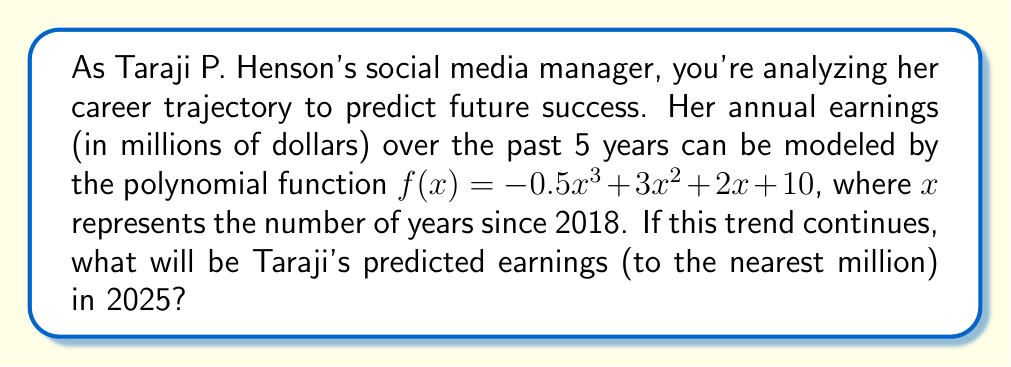Solve this math problem. To solve this problem, we need to follow these steps:

1. Identify the year we're predicting for: 2025
2. Calculate how many years this is from our starting point (2018)
3. Plug this value into our polynomial function
4. Round the result to the nearest million

Step 1: The target year is 2025

Step 2: 2025 is 7 years after 2018, so $x = 7$

Step 3: Let's plug $x = 7$ into our function:

$f(7) = -0.5(7^3) + 3(7^2) + 2(7) + 10$

Simplify:
$f(7) = -0.5(343) + 3(49) + 14 + 10$
$f(7) = -171.5 + 147 + 14 + 10$
$f(7) = -0.5$

Step 4: Rounding to the nearest million:
$-0.5$ million rounds to $0$ million

Therefore, if this polynomial trend continues, Taraji P. Henson's predicted earnings in 2025 would be approximately $0 million.

Note: This result suggests a significant downturn in earnings, which may not be realistic. In practice, career trajectories are complex and influenced by many factors not captured in this simple model.
Answer: $0 million 